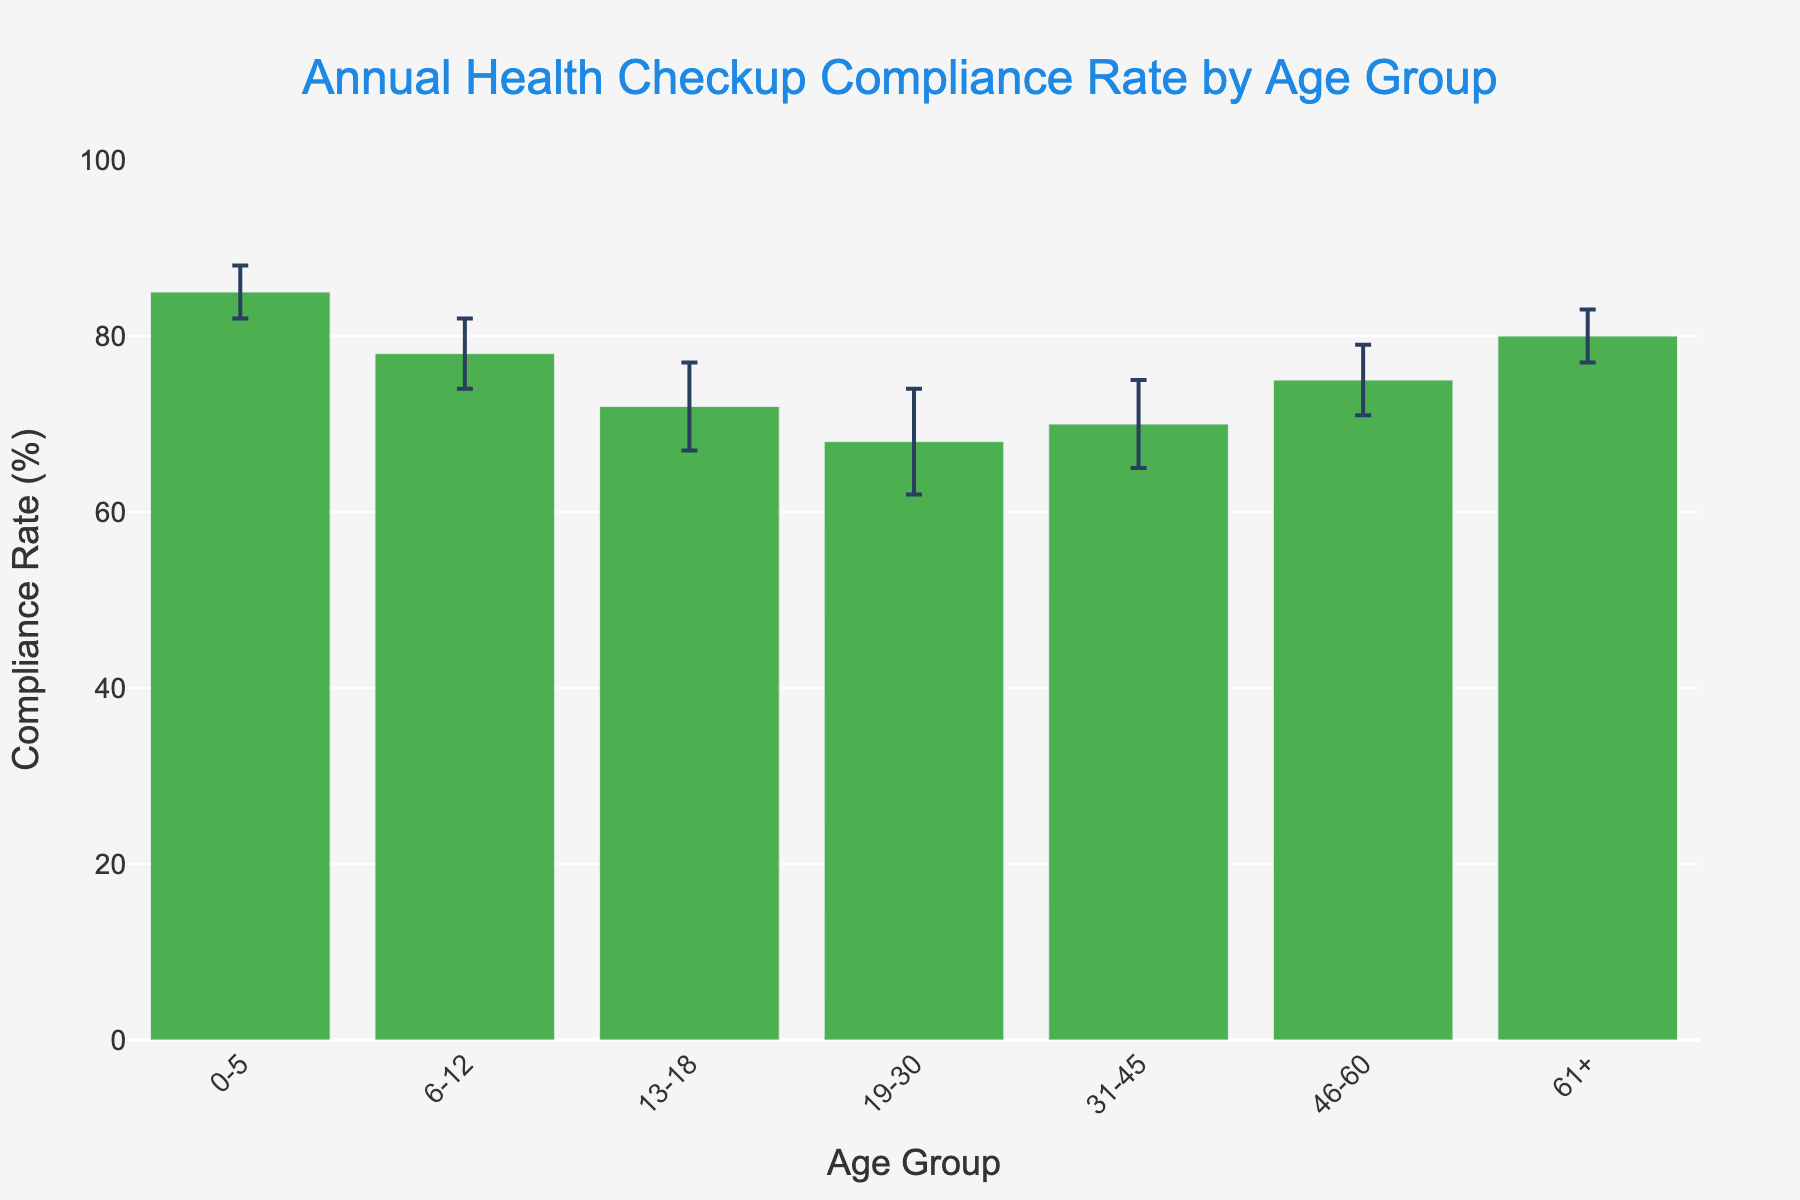What is the title of the figure? The title can be seen at the top of the chart. The title is formatted with a specific font size and color for emphasis.
Answer: Annual Health Checkup Compliance Rate by Age Group Which age group has the highest compliance rate? Observing the height of the bars and the values on the y-axis indicates that the age group with the highest bar has the highest compliance rate.
Answer: 0-5 What is the compliance rate of the 13-18 age group? Check the height of the bar corresponding to the 13-18 age group and read its value against the y-axis.
Answer: 72% Which age group has the smallest margin of error? Examine the error bars (vertical lines) extending above and below each bar. The shortest error bars indicate the smallest margin of error.
Answer: 0-5 and 61+ How much higher is the compliance rate for the 0-5 age group compared to the 13-18 age group? Subtract the compliance rate of the 13-18 age group from the compliance rate of the 0-5 age group.
Answer: 13% (85% - 72%) Which age groups have compliance rates closest to each other? Compare the heights of the bars to see which ones are nearly at the same level.
Answer: 31-45 and 46-60 What is the average compliance rate across all age groups? Sum the compliance rates of all the age groups (85+78+72+68+70+75+80) and divide by the number of age groups.
Answer: 75.43% Which age group has the largest margin of error, and what is its value? Identify the age group with the longest error bars and read its value from the plot.
Answer: 19-30, 6% Are there any age groups where the compliance rates fall below 70%? Observe the heights of the bars and identify any that are below the 70% mark on the y-axis.
Answer: Yes, 13-18 and 19-30 are below 70% 